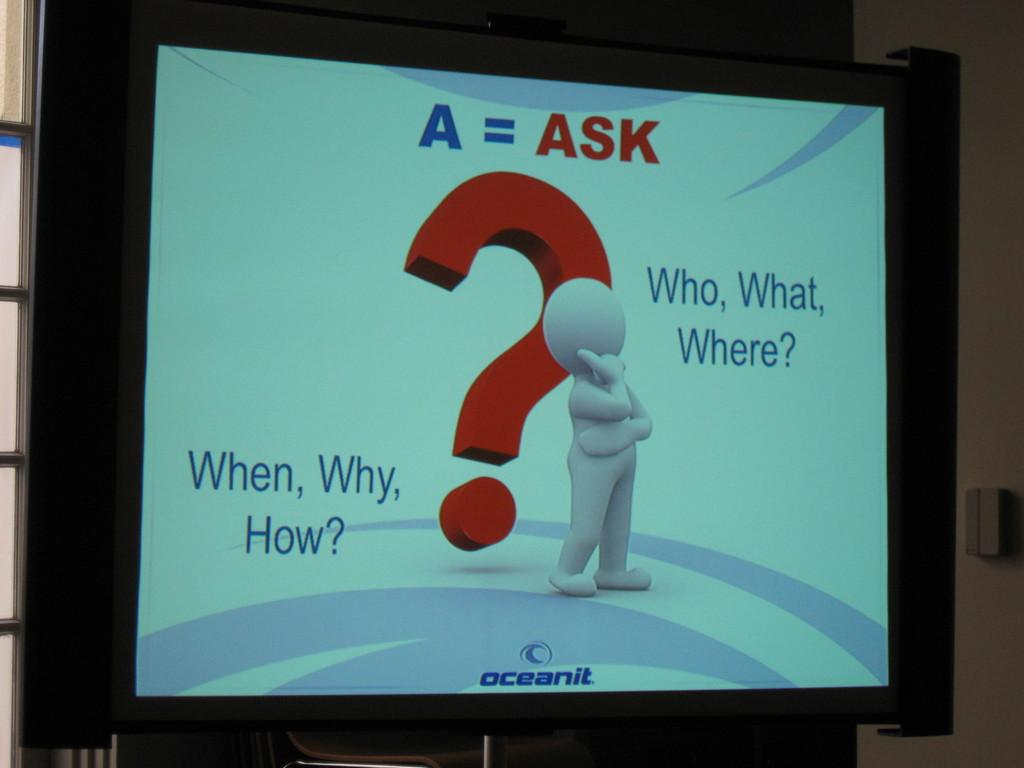<image>
Offer a succinct explanation of the picture presented. A large screen that says Oceanit on the bottom and A= ASK on top. 